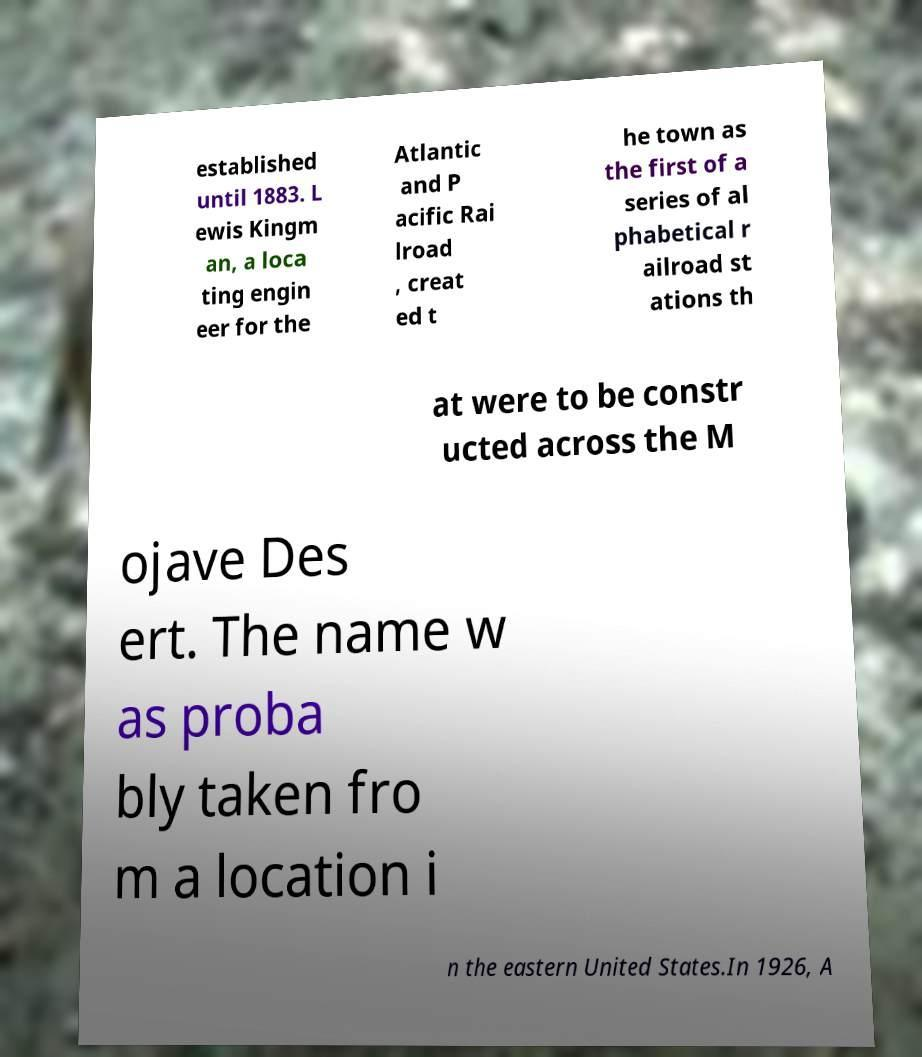Please read and relay the text visible in this image. What does it say? established until 1883. L ewis Kingm an, a loca ting engin eer for the Atlantic and P acific Rai lroad , creat ed t he town as the first of a series of al phabetical r ailroad st ations th at were to be constr ucted across the M ojave Des ert. The name w as proba bly taken fro m a location i n the eastern United States.In 1926, A 